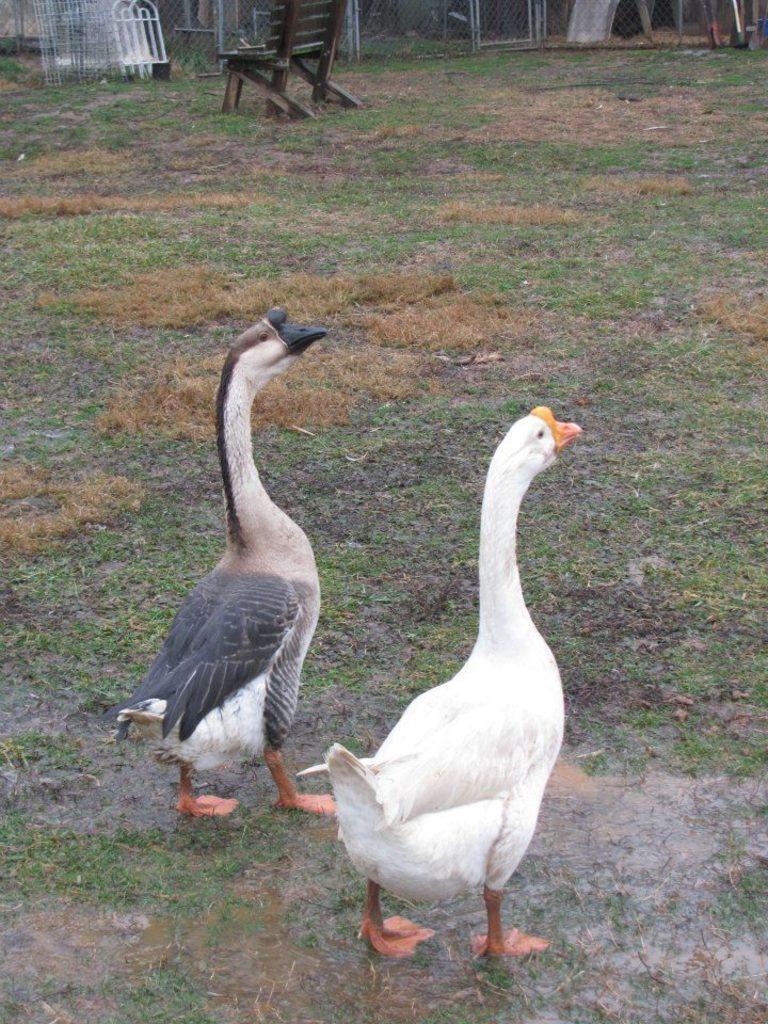Describe this image in one or two sentences. In this picture we can see birds, grass and chair. In the background of the image we can see fence. 